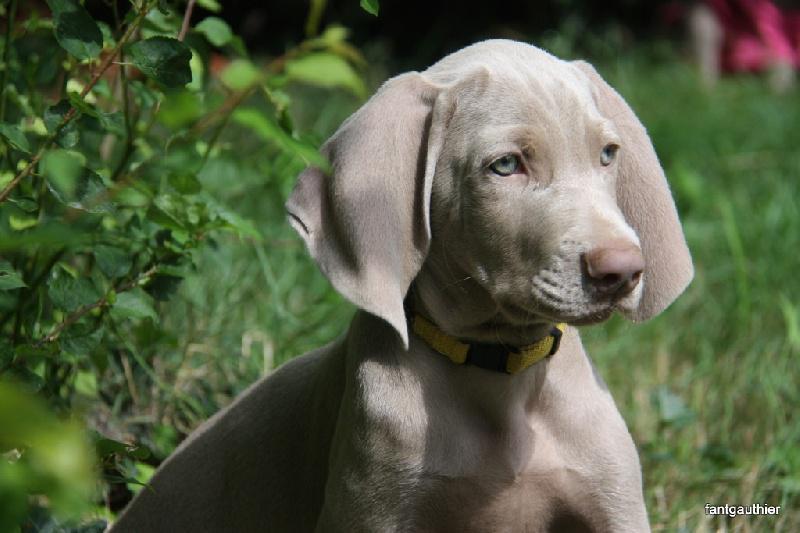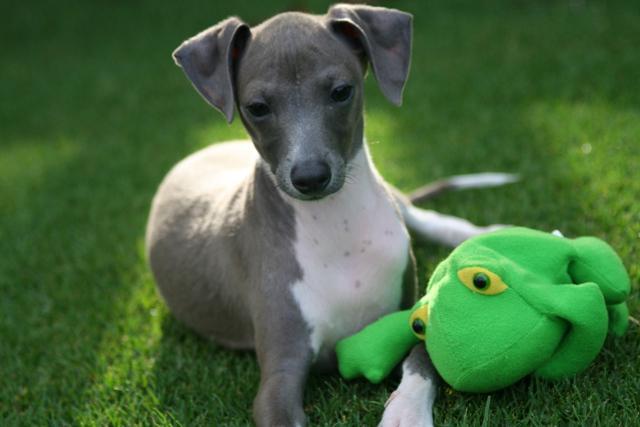The first image is the image on the left, the second image is the image on the right. Given the left and right images, does the statement "In both images the dogs are on the grass." hold true? Answer yes or no. Yes. The first image is the image on the left, the second image is the image on the right. For the images displayed, is the sentence "There is one dog with a red collar around its neck." factually correct? Answer yes or no. No. 